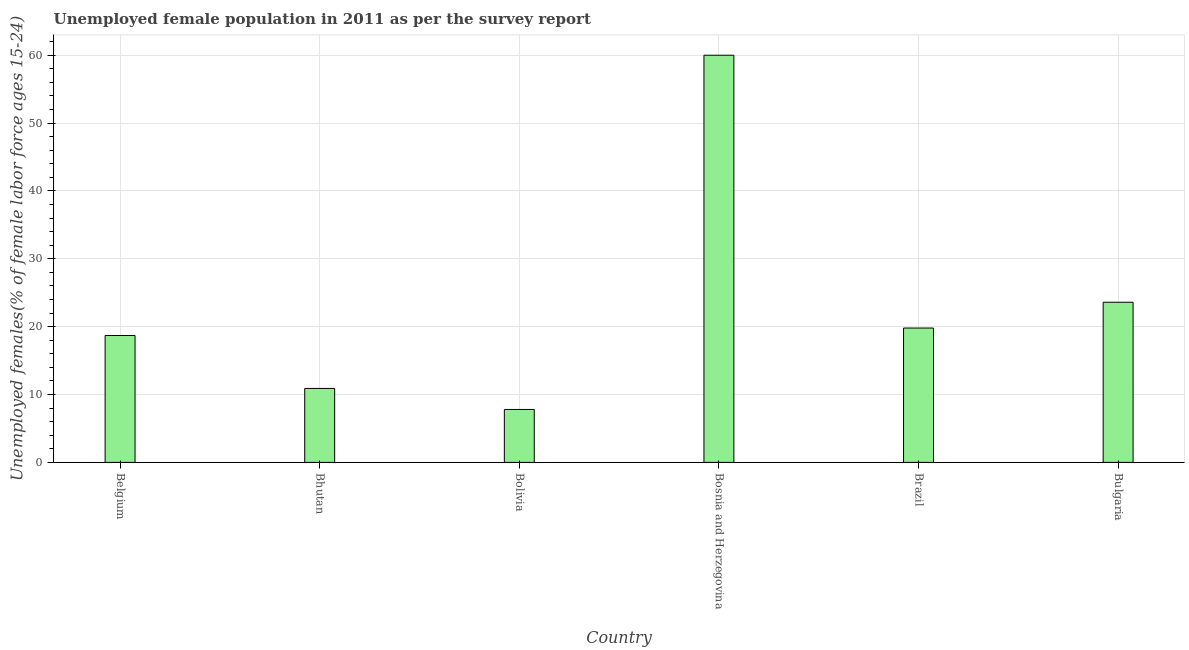Does the graph contain grids?
Your answer should be compact. Yes. What is the title of the graph?
Your response must be concise. Unemployed female population in 2011 as per the survey report. What is the label or title of the Y-axis?
Ensure brevity in your answer.  Unemployed females(% of female labor force ages 15-24). What is the unemployed female youth in Bulgaria?
Give a very brief answer. 23.6. Across all countries, what is the maximum unemployed female youth?
Make the answer very short. 60. Across all countries, what is the minimum unemployed female youth?
Provide a succinct answer. 7.8. In which country was the unemployed female youth maximum?
Make the answer very short. Bosnia and Herzegovina. What is the sum of the unemployed female youth?
Ensure brevity in your answer.  140.8. What is the average unemployed female youth per country?
Ensure brevity in your answer.  23.47. What is the median unemployed female youth?
Your answer should be very brief. 19.25. In how many countries, is the unemployed female youth greater than 22 %?
Offer a terse response. 2. What is the ratio of the unemployed female youth in Belgium to that in Bolivia?
Keep it short and to the point. 2.4. What is the difference between the highest and the second highest unemployed female youth?
Your answer should be very brief. 36.4. Is the sum of the unemployed female youth in Belgium and Brazil greater than the maximum unemployed female youth across all countries?
Keep it short and to the point. No. What is the difference between the highest and the lowest unemployed female youth?
Make the answer very short. 52.2. In how many countries, is the unemployed female youth greater than the average unemployed female youth taken over all countries?
Provide a succinct answer. 2. How many bars are there?
Your answer should be very brief. 6. Are all the bars in the graph horizontal?
Provide a short and direct response. No. How many countries are there in the graph?
Offer a very short reply. 6. What is the Unemployed females(% of female labor force ages 15-24) in Belgium?
Your answer should be compact. 18.7. What is the Unemployed females(% of female labor force ages 15-24) of Bhutan?
Offer a very short reply. 10.9. What is the Unemployed females(% of female labor force ages 15-24) of Bolivia?
Give a very brief answer. 7.8. What is the Unemployed females(% of female labor force ages 15-24) of Brazil?
Make the answer very short. 19.8. What is the Unemployed females(% of female labor force ages 15-24) of Bulgaria?
Make the answer very short. 23.6. What is the difference between the Unemployed females(% of female labor force ages 15-24) in Belgium and Bhutan?
Your answer should be compact. 7.8. What is the difference between the Unemployed females(% of female labor force ages 15-24) in Belgium and Bosnia and Herzegovina?
Make the answer very short. -41.3. What is the difference between the Unemployed females(% of female labor force ages 15-24) in Belgium and Brazil?
Ensure brevity in your answer.  -1.1. What is the difference between the Unemployed females(% of female labor force ages 15-24) in Bhutan and Bosnia and Herzegovina?
Ensure brevity in your answer.  -49.1. What is the difference between the Unemployed females(% of female labor force ages 15-24) in Bhutan and Bulgaria?
Your answer should be compact. -12.7. What is the difference between the Unemployed females(% of female labor force ages 15-24) in Bolivia and Bosnia and Herzegovina?
Ensure brevity in your answer.  -52.2. What is the difference between the Unemployed females(% of female labor force ages 15-24) in Bolivia and Bulgaria?
Offer a very short reply. -15.8. What is the difference between the Unemployed females(% of female labor force ages 15-24) in Bosnia and Herzegovina and Brazil?
Provide a succinct answer. 40.2. What is the difference between the Unemployed females(% of female labor force ages 15-24) in Bosnia and Herzegovina and Bulgaria?
Ensure brevity in your answer.  36.4. What is the ratio of the Unemployed females(% of female labor force ages 15-24) in Belgium to that in Bhutan?
Your response must be concise. 1.72. What is the ratio of the Unemployed females(% of female labor force ages 15-24) in Belgium to that in Bolivia?
Provide a succinct answer. 2.4. What is the ratio of the Unemployed females(% of female labor force ages 15-24) in Belgium to that in Bosnia and Herzegovina?
Your response must be concise. 0.31. What is the ratio of the Unemployed females(% of female labor force ages 15-24) in Belgium to that in Brazil?
Make the answer very short. 0.94. What is the ratio of the Unemployed females(% of female labor force ages 15-24) in Belgium to that in Bulgaria?
Offer a very short reply. 0.79. What is the ratio of the Unemployed females(% of female labor force ages 15-24) in Bhutan to that in Bolivia?
Your response must be concise. 1.4. What is the ratio of the Unemployed females(% of female labor force ages 15-24) in Bhutan to that in Bosnia and Herzegovina?
Your answer should be very brief. 0.18. What is the ratio of the Unemployed females(% of female labor force ages 15-24) in Bhutan to that in Brazil?
Ensure brevity in your answer.  0.55. What is the ratio of the Unemployed females(% of female labor force ages 15-24) in Bhutan to that in Bulgaria?
Make the answer very short. 0.46. What is the ratio of the Unemployed females(% of female labor force ages 15-24) in Bolivia to that in Bosnia and Herzegovina?
Offer a very short reply. 0.13. What is the ratio of the Unemployed females(% of female labor force ages 15-24) in Bolivia to that in Brazil?
Provide a short and direct response. 0.39. What is the ratio of the Unemployed females(% of female labor force ages 15-24) in Bolivia to that in Bulgaria?
Provide a succinct answer. 0.33. What is the ratio of the Unemployed females(% of female labor force ages 15-24) in Bosnia and Herzegovina to that in Brazil?
Offer a very short reply. 3.03. What is the ratio of the Unemployed females(% of female labor force ages 15-24) in Bosnia and Herzegovina to that in Bulgaria?
Offer a very short reply. 2.54. What is the ratio of the Unemployed females(% of female labor force ages 15-24) in Brazil to that in Bulgaria?
Keep it short and to the point. 0.84. 